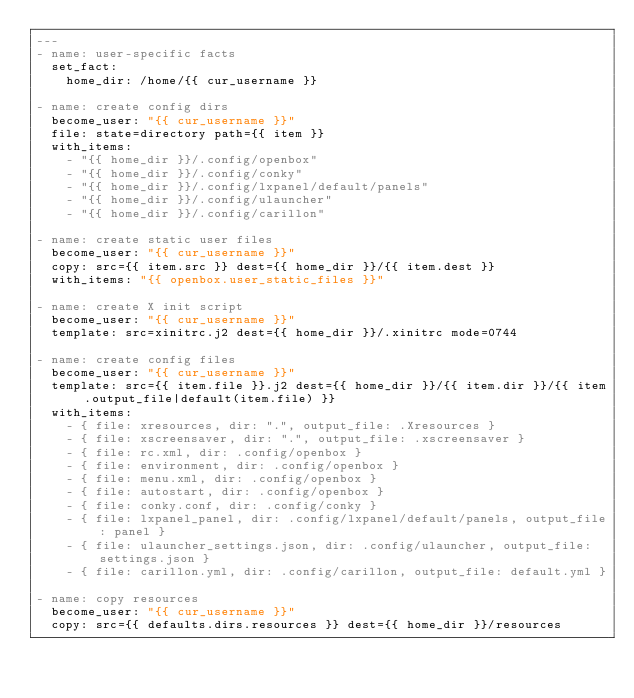<code> <loc_0><loc_0><loc_500><loc_500><_YAML_>---
- name: user-specific facts
  set_fact:
    home_dir: /home/{{ cur_username }}

- name: create config dirs
  become_user: "{{ cur_username }}"
  file: state=directory path={{ item }}
  with_items:
    - "{{ home_dir }}/.config/openbox"
    - "{{ home_dir }}/.config/conky"
    - "{{ home_dir }}/.config/lxpanel/default/panels"
    - "{{ home_dir }}/.config/ulauncher"
    - "{{ home_dir }}/.config/carillon"

- name: create static user files
  become_user: "{{ cur_username }}"
  copy: src={{ item.src }} dest={{ home_dir }}/{{ item.dest }}
  with_items: "{{ openbox.user_static_files }}"

- name: create X init script
  become_user: "{{ cur_username }}"
  template: src=xinitrc.j2 dest={{ home_dir }}/.xinitrc mode=0744

- name: create config files
  become_user: "{{ cur_username }}"
  template: src={{ item.file }}.j2 dest={{ home_dir }}/{{ item.dir }}/{{ item.output_file|default(item.file) }}
  with_items:
    - { file: xresources, dir: ".", output_file: .Xresources }
    - { file: xscreensaver, dir: ".", output_file: .xscreensaver }
    - { file: rc.xml, dir: .config/openbox }
    - { file: environment, dir: .config/openbox }
    - { file: menu.xml, dir: .config/openbox }
    - { file: autostart, dir: .config/openbox }
    - { file: conky.conf, dir: .config/conky }
    - { file: lxpanel_panel, dir: .config/lxpanel/default/panels, output_file: panel }
    - { file: ulauncher_settings.json, dir: .config/ulauncher, output_file: settings.json }
    - { file: carillon.yml, dir: .config/carillon, output_file: default.yml }

- name: copy resources
  become_user: "{{ cur_username }}"
  copy: src={{ defaults.dirs.resources }} dest={{ home_dir }}/resources
</code> 